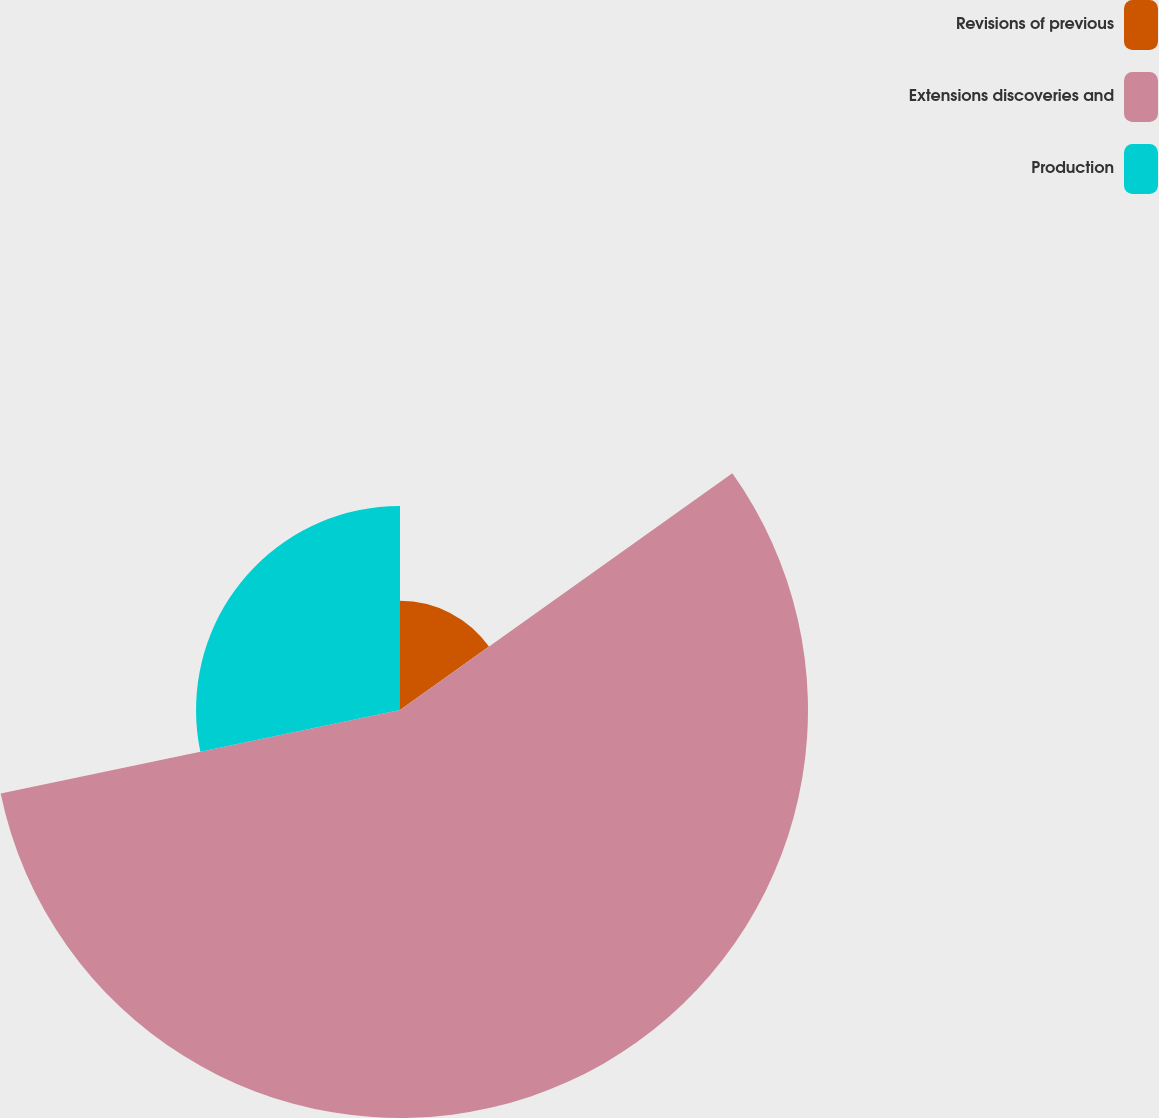Convert chart to OTSL. <chart><loc_0><loc_0><loc_500><loc_500><pie_chart><fcel>Revisions of previous<fcel>Extensions discoveries and<fcel>Production<nl><fcel>15.15%<fcel>56.57%<fcel>28.28%<nl></chart> 